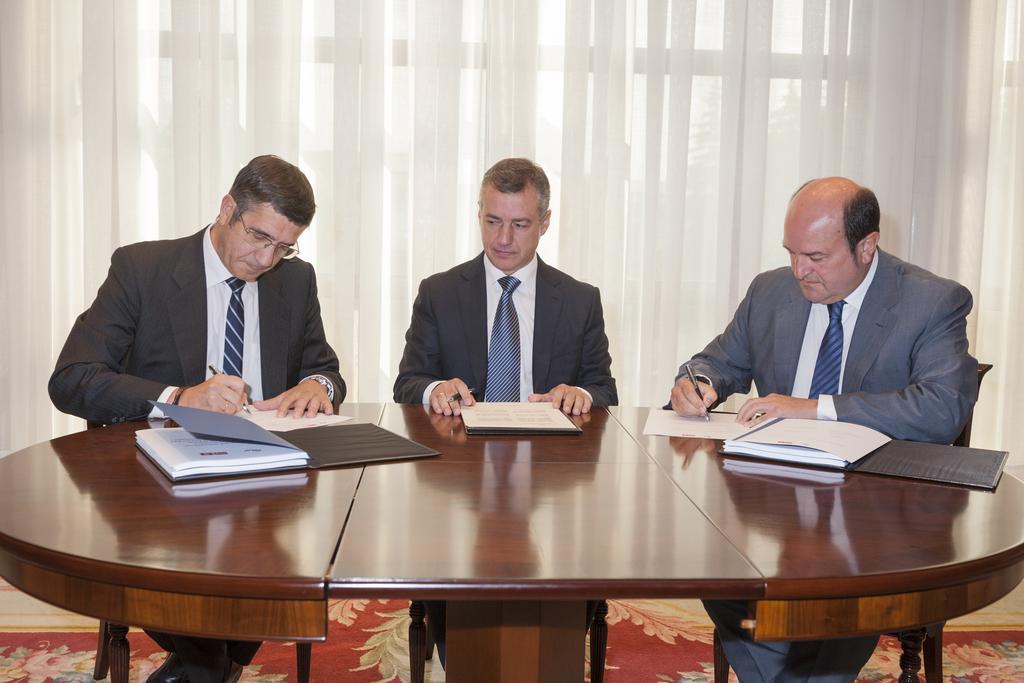Please provide a concise description of this image. It is a conference room,there is a brown color table there are some books on the table, in front of the table there are three men sitting, they are writing something on the book, in the background there is a white color curtain. 